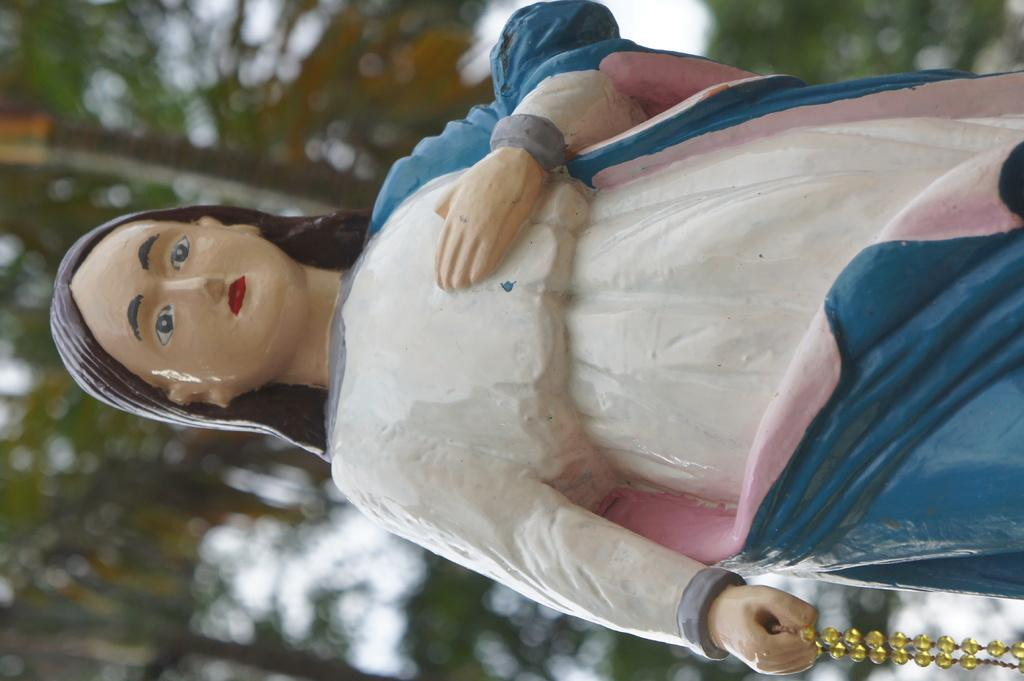What is the main subject in the image? There is a statue in the image. What can be seen in the background of the image? There are trees in the background of the image. Is there a carriage being pulled by horses in the image? No, there is no carriage or horses present in the image. 